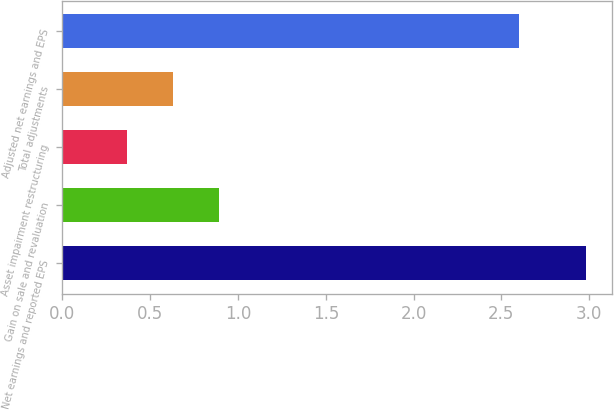Convert chart to OTSL. <chart><loc_0><loc_0><loc_500><loc_500><bar_chart><fcel>Net earnings and reported EPS<fcel>Gain on sale and revaluation<fcel>Asset impairment restructuring<fcel>Total adjustments<fcel>Adjusted net earnings and EPS<nl><fcel>2.98<fcel>0.89<fcel>0.37<fcel>0.63<fcel>2.6<nl></chart> 